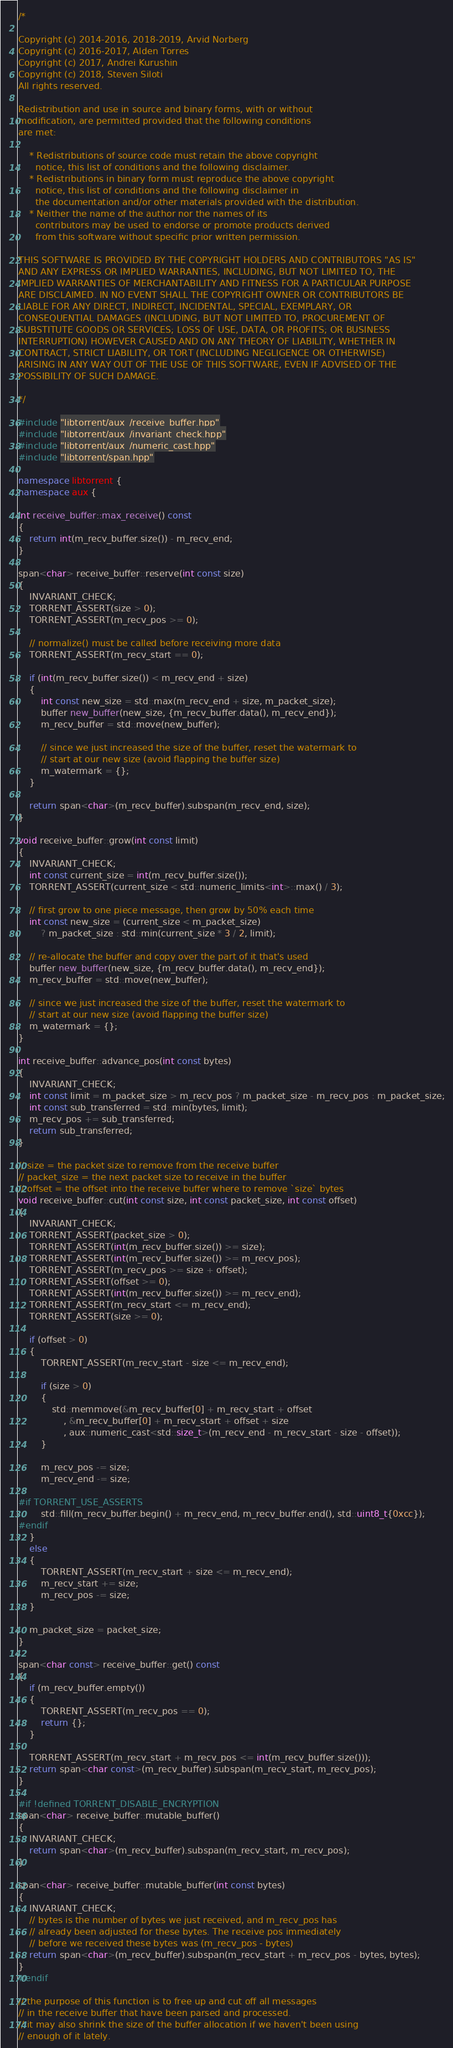Convert code to text. <code><loc_0><loc_0><loc_500><loc_500><_C++_>/*

Copyright (c) 2014-2016, 2018-2019, Arvid Norberg
Copyright (c) 2016-2017, Alden Torres
Copyright (c) 2017, Andrei Kurushin
Copyright (c) 2018, Steven Siloti
All rights reserved.

Redistribution and use in source and binary forms, with or without
modification, are permitted provided that the following conditions
are met:

    * Redistributions of source code must retain the above copyright
      notice, this list of conditions and the following disclaimer.
    * Redistributions in binary form must reproduce the above copyright
      notice, this list of conditions and the following disclaimer in
      the documentation and/or other materials provided with the distribution.
    * Neither the name of the author nor the names of its
      contributors may be used to endorse or promote products derived
      from this software without specific prior written permission.

THIS SOFTWARE IS PROVIDED BY THE COPYRIGHT HOLDERS AND CONTRIBUTORS "AS IS"
AND ANY EXPRESS OR IMPLIED WARRANTIES, INCLUDING, BUT NOT LIMITED TO, THE
IMPLIED WARRANTIES OF MERCHANTABILITY AND FITNESS FOR A PARTICULAR PURPOSE
ARE DISCLAIMED. IN NO EVENT SHALL THE COPYRIGHT OWNER OR CONTRIBUTORS BE
LIABLE FOR ANY DIRECT, INDIRECT, INCIDENTAL, SPECIAL, EXEMPLARY, OR
CONSEQUENTIAL DAMAGES (INCLUDING, BUT NOT LIMITED TO, PROCUREMENT OF
SUBSTITUTE GOODS OR SERVICES; LOSS OF USE, DATA, OR PROFITS; OR BUSINESS
INTERRUPTION) HOWEVER CAUSED AND ON ANY THEORY OF LIABILITY, WHETHER IN
CONTRACT, STRICT LIABILITY, OR TORT (INCLUDING NEGLIGENCE OR OTHERWISE)
ARISING IN ANY WAY OUT OF THE USE OF THIS SOFTWARE, EVEN IF ADVISED OF THE
POSSIBILITY OF SUCH DAMAGE.

*/

#include "libtorrent/aux_/receive_buffer.hpp"
#include "libtorrent/aux_/invariant_check.hpp"
#include "libtorrent/aux_/numeric_cast.hpp"
#include "libtorrent/span.hpp"

namespace libtorrent {
namespace aux {

int receive_buffer::max_receive() const
{
	return int(m_recv_buffer.size()) - m_recv_end;
}

span<char> receive_buffer::reserve(int const size)
{
	INVARIANT_CHECK;
	TORRENT_ASSERT(size > 0);
	TORRENT_ASSERT(m_recv_pos >= 0);

	// normalize() must be called before receiving more data
	TORRENT_ASSERT(m_recv_start == 0);

	if (int(m_recv_buffer.size()) < m_recv_end + size)
	{
		int const new_size = std::max(m_recv_end + size, m_packet_size);
		buffer new_buffer(new_size, {m_recv_buffer.data(), m_recv_end});
		m_recv_buffer = std::move(new_buffer);

		// since we just increased the size of the buffer, reset the watermark to
		// start at our new size (avoid flapping the buffer size)
		m_watermark = {};
	}

	return span<char>(m_recv_buffer).subspan(m_recv_end, size);
}

void receive_buffer::grow(int const limit)
{
	INVARIANT_CHECK;
	int const current_size = int(m_recv_buffer.size());
	TORRENT_ASSERT(current_size < std::numeric_limits<int>::max() / 3);

	// first grow to one piece message, then grow by 50% each time
	int const new_size = (current_size < m_packet_size)
		? m_packet_size : std::min(current_size * 3 / 2, limit);

	// re-allocate the buffer and copy over the part of it that's used
	buffer new_buffer(new_size, {m_recv_buffer.data(), m_recv_end});
	m_recv_buffer = std::move(new_buffer);

	// since we just increased the size of the buffer, reset the watermark to
	// start at our new size (avoid flapping the buffer size)
	m_watermark = {};
}

int receive_buffer::advance_pos(int const bytes)
{
	INVARIANT_CHECK;
	int const limit = m_packet_size > m_recv_pos ? m_packet_size - m_recv_pos : m_packet_size;
	int const sub_transferred = std::min(bytes, limit);
	m_recv_pos += sub_transferred;
	return sub_transferred;
}

// size = the packet size to remove from the receive buffer
// packet_size = the next packet size to receive in the buffer
// offset = the offset into the receive buffer where to remove `size` bytes
void receive_buffer::cut(int const size, int const packet_size, int const offset)
{
	INVARIANT_CHECK;
	TORRENT_ASSERT(packet_size > 0);
	TORRENT_ASSERT(int(m_recv_buffer.size()) >= size);
	TORRENT_ASSERT(int(m_recv_buffer.size()) >= m_recv_pos);
	TORRENT_ASSERT(m_recv_pos >= size + offset);
	TORRENT_ASSERT(offset >= 0);
	TORRENT_ASSERT(int(m_recv_buffer.size()) >= m_recv_end);
	TORRENT_ASSERT(m_recv_start <= m_recv_end);
	TORRENT_ASSERT(size >= 0);

	if (offset > 0)
	{
		TORRENT_ASSERT(m_recv_start - size <= m_recv_end);

		if (size > 0)
		{
			std::memmove(&m_recv_buffer[0] + m_recv_start + offset
				, &m_recv_buffer[0] + m_recv_start + offset + size
				, aux::numeric_cast<std::size_t>(m_recv_end - m_recv_start - size - offset));
		}

		m_recv_pos -= size;
		m_recv_end -= size;

#if TORRENT_USE_ASSERTS
		std::fill(m_recv_buffer.begin() + m_recv_end, m_recv_buffer.end(), std::uint8_t{0xcc});
#endif
	}
	else
	{
		TORRENT_ASSERT(m_recv_start + size <= m_recv_end);
		m_recv_start += size;
		m_recv_pos -= size;
	}

	m_packet_size = packet_size;
}

span<char const> receive_buffer::get() const
{
	if (m_recv_buffer.empty())
	{
		TORRENT_ASSERT(m_recv_pos == 0);
		return {};
	}

	TORRENT_ASSERT(m_recv_start + m_recv_pos <= int(m_recv_buffer.size()));
	return span<char const>(m_recv_buffer).subspan(m_recv_start, m_recv_pos);
}

#if !defined TORRENT_DISABLE_ENCRYPTION
span<char> receive_buffer::mutable_buffer()
{
	INVARIANT_CHECK;
	return span<char>(m_recv_buffer).subspan(m_recv_start, m_recv_pos);
}

span<char> receive_buffer::mutable_buffer(int const bytes)
{
	INVARIANT_CHECK;
	// bytes is the number of bytes we just received, and m_recv_pos has
	// already been adjusted for these bytes. The receive pos immediately
	// before we received these bytes was (m_recv_pos - bytes)
	return span<char>(m_recv_buffer).subspan(m_recv_start + m_recv_pos - bytes, bytes);
}
#endif

// the purpose of this function is to free up and cut off all messages
// in the receive buffer that have been parsed and processed.
// it may also shrink the size of the buffer allocation if we haven't been using
// enough of it lately.</code> 